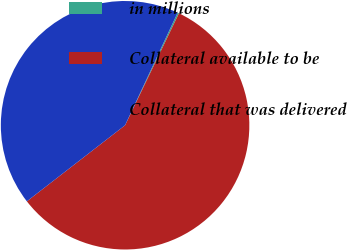Convert chart. <chart><loc_0><loc_0><loc_500><loc_500><pie_chart><fcel>in millions<fcel>Collateral available to be<fcel>Collateral that was delivered<nl><fcel>0.19%<fcel>57.37%<fcel>42.44%<nl></chart> 